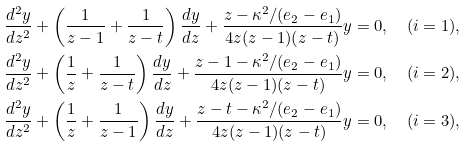<formula> <loc_0><loc_0><loc_500><loc_500>& \frac { d ^ { 2 } y } { d z ^ { 2 } } + \left ( \frac { 1 } { z - 1 } + \frac { 1 } { z - t } \right ) \frac { d y } { d z } + \frac { z - \kappa ^ { 2 } / ( e _ { 2 } - e _ { 1 } ) } { 4 z ( z - 1 ) ( z - t ) } y = 0 , \quad ( i = 1 ) , \\ & \frac { d ^ { 2 } y } { d z ^ { 2 } } + \left ( \frac { 1 } { z } + \frac { 1 } { z - t } \right ) \frac { d y } { d z } + \frac { z - 1 - \kappa ^ { 2 } / ( e _ { 2 } - e _ { 1 } ) } { 4 z ( z - 1 ) ( z - t ) } y = 0 , \quad ( i = 2 ) , \\ & \frac { d ^ { 2 } y } { d z ^ { 2 } } + \left ( \frac { 1 } { z } + \frac { 1 } { z - 1 } \right ) \frac { d y } { d z } + \frac { z - t - \kappa ^ { 2 } / ( e _ { 2 } - e _ { 1 } ) } { 4 z ( z - 1 ) ( z - t ) } y = 0 , \quad ( i = 3 ) ,</formula> 